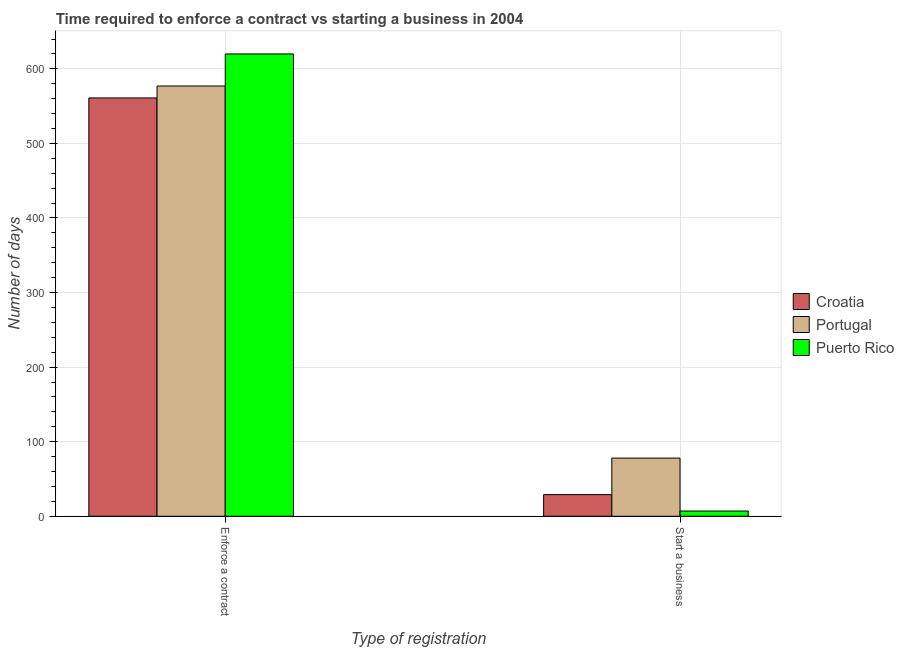How many groups of bars are there?
Provide a succinct answer. 2. Are the number of bars on each tick of the X-axis equal?
Your response must be concise. Yes. How many bars are there on the 1st tick from the left?
Ensure brevity in your answer.  3. How many bars are there on the 1st tick from the right?
Ensure brevity in your answer.  3. What is the label of the 2nd group of bars from the left?
Your response must be concise. Start a business. What is the number of days to enforece a contract in Croatia?
Your answer should be compact. 561. Across all countries, what is the maximum number of days to enforece a contract?
Provide a short and direct response. 620. Across all countries, what is the minimum number of days to start a business?
Offer a terse response. 7. In which country was the number of days to enforece a contract maximum?
Provide a short and direct response. Puerto Rico. In which country was the number of days to start a business minimum?
Provide a succinct answer. Puerto Rico. What is the total number of days to start a business in the graph?
Offer a very short reply. 114. What is the difference between the number of days to start a business in Croatia and that in Portugal?
Offer a very short reply. -49. What is the difference between the number of days to enforece a contract in Croatia and the number of days to start a business in Portugal?
Offer a terse response. 483. What is the average number of days to start a business per country?
Offer a very short reply. 38. What is the difference between the number of days to start a business and number of days to enforece a contract in Croatia?
Provide a short and direct response. -532. What is the ratio of the number of days to start a business in Puerto Rico to that in Portugal?
Provide a short and direct response. 0.09. In how many countries, is the number of days to enforece a contract greater than the average number of days to enforece a contract taken over all countries?
Provide a succinct answer. 1. What does the 3rd bar from the left in Start a business represents?
Make the answer very short. Puerto Rico. Does the graph contain grids?
Ensure brevity in your answer.  Yes. How many legend labels are there?
Your answer should be compact. 3. What is the title of the graph?
Your response must be concise. Time required to enforce a contract vs starting a business in 2004. What is the label or title of the X-axis?
Offer a very short reply. Type of registration. What is the label or title of the Y-axis?
Make the answer very short. Number of days. What is the Number of days of Croatia in Enforce a contract?
Provide a succinct answer. 561. What is the Number of days in Portugal in Enforce a contract?
Your response must be concise. 577. What is the Number of days of Puerto Rico in Enforce a contract?
Keep it short and to the point. 620. What is the Number of days in Croatia in Start a business?
Your answer should be very brief. 29. What is the Number of days in Puerto Rico in Start a business?
Your answer should be very brief. 7. Across all Type of registration, what is the maximum Number of days in Croatia?
Provide a short and direct response. 561. Across all Type of registration, what is the maximum Number of days of Portugal?
Offer a very short reply. 577. Across all Type of registration, what is the maximum Number of days of Puerto Rico?
Make the answer very short. 620. Across all Type of registration, what is the minimum Number of days of Portugal?
Offer a terse response. 78. Across all Type of registration, what is the minimum Number of days of Puerto Rico?
Ensure brevity in your answer.  7. What is the total Number of days in Croatia in the graph?
Offer a very short reply. 590. What is the total Number of days in Portugal in the graph?
Ensure brevity in your answer.  655. What is the total Number of days in Puerto Rico in the graph?
Give a very brief answer. 627. What is the difference between the Number of days of Croatia in Enforce a contract and that in Start a business?
Make the answer very short. 532. What is the difference between the Number of days in Portugal in Enforce a contract and that in Start a business?
Offer a very short reply. 499. What is the difference between the Number of days of Puerto Rico in Enforce a contract and that in Start a business?
Give a very brief answer. 613. What is the difference between the Number of days of Croatia in Enforce a contract and the Number of days of Portugal in Start a business?
Make the answer very short. 483. What is the difference between the Number of days in Croatia in Enforce a contract and the Number of days in Puerto Rico in Start a business?
Provide a succinct answer. 554. What is the difference between the Number of days of Portugal in Enforce a contract and the Number of days of Puerto Rico in Start a business?
Your answer should be compact. 570. What is the average Number of days in Croatia per Type of registration?
Give a very brief answer. 295. What is the average Number of days in Portugal per Type of registration?
Your answer should be compact. 327.5. What is the average Number of days in Puerto Rico per Type of registration?
Give a very brief answer. 313.5. What is the difference between the Number of days in Croatia and Number of days in Puerto Rico in Enforce a contract?
Keep it short and to the point. -59. What is the difference between the Number of days in Portugal and Number of days in Puerto Rico in Enforce a contract?
Provide a succinct answer. -43. What is the difference between the Number of days in Croatia and Number of days in Portugal in Start a business?
Your answer should be very brief. -49. What is the difference between the Number of days of Portugal and Number of days of Puerto Rico in Start a business?
Make the answer very short. 71. What is the ratio of the Number of days in Croatia in Enforce a contract to that in Start a business?
Make the answer very short. 19.34. What is the ratio of the Number of days in Portugal in Enforce a contract to that in Start a business?
Your response must be concise. 7.4. What is the ratio of the Number of days of Puerto Rico in Enforce a contract to that in Start a business?
Your answer should be very brief. 88.57. What is the difference between the highest and the second highest Number of days in Croatia?
Your answer should be compact. 532. What is the difference between the highest and the second highest Number of days of Portugal?
Make the answer very short. 499. What is the difference between the highest and the second highest Number of days in Puerto Rico?
Give a very brief answer. 613. What is the difference between the highest and the lowest Number of days in Croatia?
Provide a short and direct response. 532. What is the difference between the highest and the lowest Number of days in Portugal?
Give a very brief answer. 499. What is the difference between the highest and the lowest Number of days of Puerto Rico?
Keep it short and to the point. 613. 